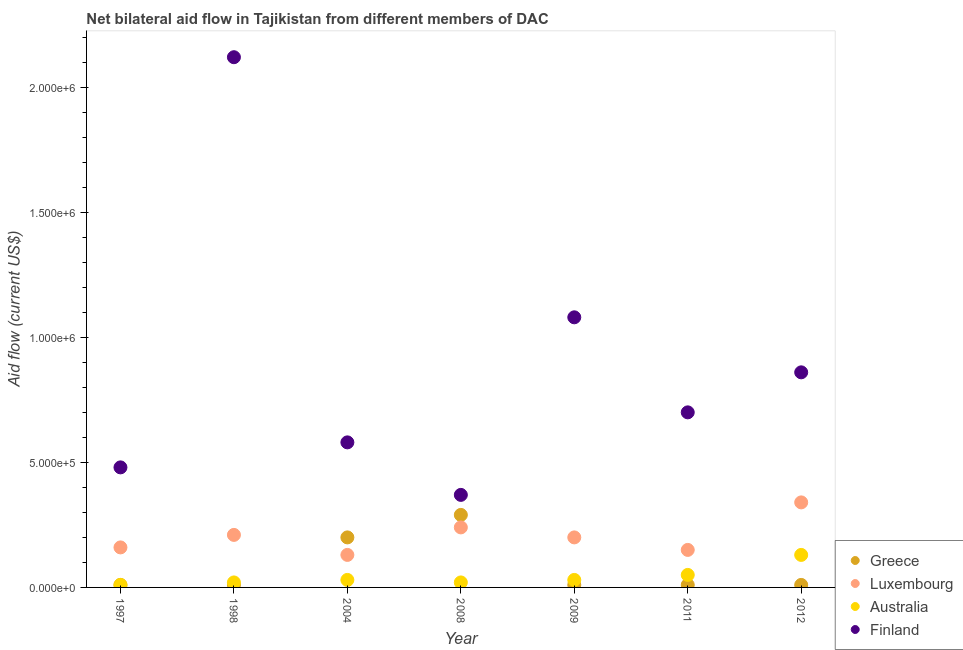How many different coloured dotlines are there?
Offer a very short reply. 4. Is the number of dotlines equal to the number of legend labels?
Your response must be concise. Yes. What is the amount of aid given by greece in 2004?
Ensure brevity in your answer.  2.00e+05. Across all years, what is the maximum amount of aid given by luxembourg?
Offer a very short reply. 3.40e+05. Across all years, what is the minimum amount of aid given by luxembourg?
Provide a short and direct response. 1.30e+05. In which year was the amount of aid given by greece maximum?
Your response must be concise. 2008. What is the total amount of aid given by luxembourg in the graph?
Your answer should be very brief. 1.43e+06. What is the difference between the amount of aid given by greece in 1997 and that in 2008?
Your response must be concise. -2.80e+05. What is the difference between the amount of aid given by greece in 2011 and the amount of aid given by australia in 2009?
Keep it short and to the point. -2.00e+04. What is the average amount of aid given by finland per year?
Make the answer very short. 8.84e+05. In the year 2009, what is the difference between the amount of aid given by luxembourg and amount of aid given by greece?
Offer a very short reply. 1.90e+05. What is the ratio of the amount of aid given by australia in 2011 to that in 2012?
Keep it short and to the point. 0.38. Is the difference between the amount of aid given by greece in 2004 and 2008 greater than the difference between the amount of aid given by luxembourg in 2004 and 2008?
Your answer should be very brief. Yes. What is the difference between the highest and the lowest amount of aid given by australia?
Give a very brief answer. 1.20e+05. In how many years, is the amount of aid given by luxembourg greater than the average amount of aid given by luxembourg taken over all years?
Offer a very short reply. 3. Is it the case that in every year, the sum of the amount of aid given by greece and amount of aid given by luxembourg is greater than the amount of aid given by australia?
Offer a very short reply. Yes. Does the amount of aid given by greece monotonically increase over the years?
Offer a very short reply. No. Is the amount of aid given by luxembourg strictly greater than the amount of aid given by finland over the years?
Ensure brevity in your answer.  No. Is the amount of aid given by finland strictly less than the amount of aid given by australia over the years?
Make the answer very short. No. How many dotlines are there?
Your answer should be compact. 4. What is the difference between two consecutive major ticks on the Y-axis?
Offer a very short reply. 5.00e+05. Where does the legend appear in the graph?
Keep it short and to the point. Bottom right. How many legend labels are there?
Your answer should be compact. 4. What is the title of the graph?
Your answer should be very brief. Net bilateral aid flow in Tajikistan from different members of DAC. Does "Secondary general education" appear as one of the legend labels in the graph?
Make the answer very short. No. What is the label or title of the X-axis?
Provide a succinct answer. Year. What is the Aid flow (current US$) in Greece in 1997?
Your answer should be very brief. 10000. What is the Aid flow (current US$) in Finland in 1997?
Offer a very short reply. 4.80e+05. What is the Aid flow (current US$) in Greece in 1998?
Offer a very short reply. 10000. What is the Aid flow (current US$) of Luxembourg in 1998?
Ensure brevity in your answer.  2.10e+05. What is the Aid flow (current US$) in Australia in 1998?
Offer a very short reply. 2.00e+04. What is the Aid flow (current US$) of Finland in 1998?
Keep it short and to the point. 2.12e+06. What is the Aid flow (current US$) of Greece in 2004?
Your answer should be compact. 2.00e+05. What is the Aid flow (current US$) in Australia in 2004?
Keep it short and to the point. 3.00e+04. What is the Aid flow (current US$) of Finland in 2004?
Ensure brevity in your answer.  5.80e+05. What is the Aid flow (current US$) of Greece in 2008?
Offer a very short reply. 2.90e+05. What is the Aid flow (current US$) in Australia in 2008?
Provide a succinct answer. 2.00e+04. What is the Aid flow (current US$) of Finland in 2008?
Provide a succinct answer. 3.70e+05. What is the Aid flow (current US$) of Greece in 2009?
Your answer should be compact. 10000. What is the Aid flow (current US$) in Australia in 2009?
Offer a very short reply. 3.00e+04. What is the Aid flow (current US$) of Finland in 2009?
Offer a terse response. 1.08e+06. What is the Aid flow (current US$) in Greece in 2011?
Keep it short and to the point. 10000. What is the Aid flow (current US$) of Australia in 2011?
Provide a short and direct response. 5.00e+04. What is the Aid flow (current US$) of Finland in 2011?
Your response must be concise. 7.00e+05. What is the Aid flow (current US$) in Luxembourg in 2012?
Give a very brief answer. 3.40e+05. What is the Aid flow (current US$) of Finland in 2012?
Provide a short and direct response. 8.60e+05. Across all years, what is the maximum Aid flow (current US$) in Finland?
Offer a terse response. 2.12e+06. Across all years, what is the minimum Aid flow (current US$) of Luxembourg?
Make the answer very short. 1.30e+05. Across all years, what is the minimum Aid flow (current US$) in Australia?
Your answer should be very brief. 10000. Across all years, what is the minimum Aid flow (current US$) of Finland?
Make the answer very short. 3.70e+05. What is the total Aid flow (current US$) in Greece in the graph?
Your answer should be very brief. 5.40e+05. What is the total Aid flow (current US$) of Luxembourg in the graph?
Offer a terse response. 1.43e+06. What is the total Aid flow (current US$) of Finland in the graph?
Make the answer very short. 6.19e+06. What is the difference between the Aid flow (current US$) in Finland in 1997 and that in 1998?
Offer a very short reply. -1.64e+06. What is the difference between the Aid flow (current US$) in Luxembourg in 1997 and that in 2004?
Your answer should be very brief. 3.00e+04. What is the difference between the Aid flow (current US$) in Australia in 1997 and that in 2004?
Give a very brief answer. -2.00e+04. What is the difference between the Aid flow (current US$) in Greece in 1997 and that in 2008?
Give a very brief answer. -2.80e+05. What is the difference between the Aid flow (current US$) of Australia in 1997 and that in 2008?
Make the answer very short. -10000. What is the difference between the Aid flow (current US$) in Greece in 1997 and that in 2009?
Offer a very short reply. 0. What is the difference between the Aid flow (current US$) of Luxembourg in 1997 and that in 2009?
Offer a very short reply. -4.00e+04. What is the difference between the Aid flow (current US$) of Australia in 1997 and that in 2009?
Offer a very short reply. -2.00e+04. What is the difference between the Aid flow (current US$) in Finland in 1997 and that in 2009?
Provide a short and direct response. -6.00e+05. What is the difference between the Aid flow (current US$) in Greece in 1997 and that in 2011?
Make the answer very short. 0. What is the difference between the Aid flow (current US$) in Luxembourg in 1997 and that in 2011?
Ensure brevity in your answer.  10000. What is the difference between the Aid flow (current US$) in Luxembourg in 1997 and that in 2012?
Provide a short and direct response. -1.80e+05. What is the difference between the Aid flow (current US$) of Finland in 1997 and that in 2012?
Ensure brevity in your answer.  -3.80e+05. What is the difference between the Aid flow (current US$) of Greece in 1998 and that in 2004?
Provide a short and direct response. -1.90e+05. What is the difference between the Aid flow (current US$) of Finland in 1998 and that in 2004?
Keep it short and to the point. 1.54e+06. What is the difference between the Aid flow (current US$) of Greece in 1998 and that in 2008?
Offer a very short reply. -2.80e+05. What is the difference between the Aid flow (current US$) in Luxembourg in 1998 and that in 2008?
Make the answer very short. -3.00e+04. What is the difference between the Aid flow (current US$) in Australia in 1998 and that in 2008?
Offer a terse response. 0. What is the difference between the Aid flow (current US$) of Finland in 1998 and that in 2008?
Keep it short and to the point. 1.75e+06. What is the difference between the Aid flow (current US$) in Australia in 1998 and that in 2009?
Offer a very short reply. -10000. What is the difference between the Aid flow (current US$) in Finland in 1998 and that in 2009?
Provide a succinct answer. 1.04e+06. What is the difference between the Aid flow (current US$) in Greece in 1998 and that in 2011?
Provide a short and direct response. 0. What is the difference between the Aid flow (current US$) of Luxembourg in 1998 and that in 2011?
Your answer should be very brief. 6.00e+04. What is the difference between the Aid flow (current US$) in Australia in 1998 and that in 2011?
Your answer should be very brief. -3.00e+04. What is the difference between the Aid flow (current US$) in Finland in 1998 and that in 2011?
Offer a very short reply. 1.42e+06. What is the difference between the Aid flow (current US$) of Greece in 1998 and that in 2012?
Give a very brief answer. 0. What is the difference between the Aid flow (current US$) of Luxembourg in 1998 and that in 2012?
Provide a short and direct response. -1.30e+05. What is the difference between the Aid flow (current US$) of Finland in 1998 and that in 2012?
Provide a succinct answer. 1.26e+06. What is the difference between the Aid flow (current US$) of Luxembourg in 2004 and that in 2008?
Make the answer very short. -1.10e+05. What is the difference between the Aid flow (current US$) of Australia in 2004 and that in 2008?
Ensure brevity in your answer.  10000. What is the difference between the Aid flow (current US$) of Australia in 2004 and that in 2009?
Ensure brevity in your answer.  0. What is the difference between the Aid flow (current US$) in Finland in 2004 and that in 2009?
Offer a terse response. -5.00e+05. What is the difference between the Aid flow (current US$) of Greece in 2004 and that in 2011?
Ensure brevity in your answer.  1.90e+05. What is the difference between the Aid flow (current US$) in Luxembourg in 2004 and that in 2011?
Ensure brevity in your answer.  -2.00e+04. What is the difference between the Aid flow (current US$) in Australia in 2004 and that in 2011?
Give a very brief answer. -2.00e+04. What is the difference between the Aid flow (current US$) in Greece in 2004 and that in 2012?
Your response must be concise. 1.90e+05. What is the difference between the Aid flow (current US$) of Australia in 2004 and that in 2012?
Offer a very short reply. -1.00e+05. What is the difference between the Aid flow (current US$) of Finland in 2004 and that in 2012?
Your response must be concise. -2.80e+05. What is the difference between the Aid flow (current US$) of Luxembourg in 2008 and that in 2009?
Provide a succinct answer. 4.00e+04. What is the difference between the Aid flow (current US$) of Australia in 2008 and that in 2009?
Your response must be concise. -10000. What is the difference between the Aid flow (current US$) of Finland in 2008 and that in 2009?
Your response must be concise. -7.10e+05. What is the difference between the Aid flow (current US$) in Greece in 2008 and that in 2011?
Make the answer very short. 2.80e+05. What is the difference between the Aid flow (current US$) of Finland in 2008 and that in 2011?
Provide a succinct answer. -3.30e+05. What is the difference between the Aid flow (current US$) in Finland in 2008 and that in 2012?
Give a very brief answer. -4.90e+05. What is the difference between the Aid flow (current US$) of Luxembourg in 2009 and that in 2011?
Your response must be concise. 5.00e+04. What is the difference between the Aid flow (current US$) in Australia in 2009 and that in 2011?
Give a very brief answer. -2.00e+04. What is the difference between the Aid flow (current US$) in Greece in 2009 and that in 2012?
Offer a very short reply. 0. What is the difference between the Aid flow (current US$) of Luxembourg in 2009 and that in 2012?
Provide a short and direct response. -1.40e+05. What is the difference between the Aid flow (current US$) in Finland in 2009 and that in 2012?
Your answer should be very brief. 2.20e+05. What is the difference between the Aid flow (current US$) of Luxembourg in 2011 and that in 2012?
Make the answer very short. -1.90e+05. What is the difference between the Aid flow (current US$) in Australia in 2011 and that in 2012?
Your answer should be compact. -8.00e+04. What is the difference between the Aid flow (current US$) of Finland in 2011 and that in 2012?
Your answer should be compact. -1.60e+05. What is the difference between the Aid flow (current US$) of Greece in 1997 and the Aid flow (current US$) of Luxembourg in 1998?
Your response must be concise. -2.00e+05. What is the difference between the Aid flow (current US$) of Greece in 1997 and the Aid flow (current US$) of Finland in 1998?
Make the answer very short. -2.11e+06. What is the difference between the Aid flow (current US$) of Luxembourg in 1997 and the Aid flow (current US$) of Finland in 1998?
Provide a succinct answer. -1.96e+06. What is the difference between the Aid flow (current US$) of Australia in 1997 and the Aid flow (current US$) of Finland in 1998?
Provide a succinct answer. -2.11e+06. What is the difference between the Aid flow (current US$) in Greece in 1997 and the Aid flow (current US$) in Finland in 2004?
Give a very brief answer. -5.70e+05. What is the difference between the Aid flow (current US$) of Luxembourg in 1997 and the Aid flow (current US$) of Australia in 2004?
Your answer should be very brief. 1.30e+05. What is the difference between the Aid flow (current US$) of Luxembourg in 1997 and the Aid flow (current US$) of Finland in 2004?
Your answer should be very brief. -4.20e+05. What is the difference between the Aid flow (current US$) of Australia in 1997 and the Aid flow (current US$) of Finland in 2004?
Your answer should be very brief. -5.70e+05. What is the difference between the Aid flow (current US$) in Greece in 1997 and the Aid flow (current US$) in Luxembourg in 2008?
Provide a succinct answer. -2.30e+05. What is the difference between the Aid flow (current US$) in Greece in 1997 and the Aid flow (current US$) in Australia in 2008?
Your response must be concise. -10000. What is the difference between the Aid flow (current US$) of Greece in 1997 and the Aid flow (current US$) of Finland in 2008?
Give a very brief answer. -3.60e+05. What is the difference between the Aid flow (current US$) in Australia in 1997 and the Aid flow (current US$) in Finland in 2008?
Make the answer very short. -3.60e+05. What is the difference between the Aid flow (current US$) in Greece in 1997 and the Aid flow (current US$) in Australia in 2009?
Make the answer very short. -2.00e+04. What is the difference between the Aid flow (current US$) of Greece in 1997 and the Aid flow (current US$) of Finland in 2009?
Provide a succinct answer. -1.07e+06. What is the difference between the Aid flow (current US$) of Luxembourg in 1997 and the Aid flow (current US$) of Finland in 2009?
Your answer should be compact. -9.20e+05. What is the difference between the Aid flow (current US$) in Australia in 1997 and the Aid flow (current US$) in Finland in 2009?
Make the answer very short. -1.07e+06. What is the difference between the Aid flow (current US$) in Greece in 1997 and the Aid flow (current US$) in Luxembourg in 2011?
Ensure brevity in your answer.  -1.40e+05. What is the difference between the Aid flow (current US$) in Greece in 1997 and the Aid flow (current US$) in Finland in 2011?
Provide a succinct answer. -6.90e+05. What is the difference between the Aid flow (current US$) in Luxembourg in 1997 and the Aid flow (current US$) in Australia in 2011?
Ensure brevity in your answer.  1.10e+05. What is the difference between the Aid flow (current US$) in Luxembourg in 1997 and the Aid flow (current US$) in Finland in 2011?
Your answer should be very brief. -5.40e+05. What is the difference between the Aid flow (current US$) in Australia in 1997 and the Aid flow (current US$) in Finland in 2011?
Offer a very short reply. -6.90e+05. What is the difference between the Aid flow (current US$) in Greece in 1997 and the Aid flow (current US$) in Luxembourg in 2012?
Provide a succinct answer. -3.30e+05. What is the difference between the Aid flow (current US$) of Greece in 1997 and the Aid flow (current US$) of Finland in 2012?
Keep it short and to the point. -8.50e+05. What is the difference between the Aid flow (current US$) in Luxembourg in 1997 and the Aid flow (current US$) in Finland in 2012?
Offer a terse response. -7.00e+05. What is the difference between the Aid flow (current US$) in Australia in 1997 and the Aid flow (current US$) in Finland in 2012?
Your answer should be very brief. -8.50e+05. What is the difference between the Aid flow (current US$) in Greece in 1998 and the Aid flow (current US$) in Luxembourg in 2004?
Provide a short and direct response. -1.20e+05. What is the difference between the Aid flow (current US$) in Greece in 1998 and the Aid flow (current US$) in Australia in 2004?
Make the answer very short. -2.00e+04. What is the difference between the Aid flow (current US$) in Greece in 1998 and the Aid flow (current US$) in Finland in 2004?
Your response must be concise. -5.70e+05. What is the difference between the Aid flow (current US$) in Luxembourg in 1998 and the Aid flow (current US$) in Finland in 2004?
Ensure brevity in your answer.  -3.70e+05. What is the difference between the Aid flow (current US$) in Australia in 1998 and the Aid flow (current US$) in Finland in 2004?
Provide a succinct answer. -5.60e+05. What is the difference between the Aid flow (current US$) of Greece in 1998 and the Aid flow (current US$) of Luxembourg in 2008?
Offer a very short reply. -2.30e+05. What is the difference between the Aid flow (current US$) in Greece in 1998 and the Aid flow (current US$) in Finland in 2008?
Provide a short and direct response. -3.60e+05. What is the difference between the Aid flow (current US$) in Luxembourg in 1998 and the Aid flow (current US$) in Australia in 2008?
Your answer should be very brief. 1.90e+05. What is the difference between the Aid flow (current US$) in Australia in 1998 and the Aid flow (current US$) in Finland in 2008?
Offer a terse response. -3.50e+05. What is the difference between the Aid flow (current US$) in Greece in 1998 and the Aid flow (current US$) in Australia in 2009?
Give a very brief answer. -2.00e+04. What is the difference between the Aid flow (current US$) in Greece in 1998 and the Aid flow (current US$) in Finland in 2009?
Offer a very short reply. -1.07e+06. What is the difference between the Aid flow (current US$) of Luxembourg in 1998 and the Aid flow (current US$) of Australia in 2009?
Your answer should be compact. 1.80e+05. What is the difference between the Aid flow (current US$) of Luxembourg in 1998 and the Aid flow (current US$) of Finland in 2009?
Provide a short and direct response. -8.70e+05. What is the difference between the Aid flow (current US$) in Australia in 1998 and the Aid flow (current US$) in Finland in 2009?
Your answer should be compact. -1.06e+06. What is the difference between the Aid flow (current US$) of Greece in 1998 and the Aid flow (current US$) of Luxembourg in 2011?
Give a very brief answer. -1.40e+05. What is the difference between the Aid flow (current US$) in Greece in 1998 and the Aid flow (current US$) in Australia in 2011?
Keep it short and to the point. -4.00e+04. What is the difference between the Aid flow (current US$) of Greece in 1998 and the Aid flow (current US$) of Finland in 2011?
Make the answer very short. -6.90e+05. What is the difference between the Aid flow (current US$) of Luxembourg in 1998 and the Aid flow (current US$) of Australia in 2011?
Your answer should be compact. 1.60e+05. What is the difference between the Aid flow (current US$) in Luxembourg in 1998 and the Aid flow (current US$) in Finland in 2011?
Your answer should be very brief. -4.90e+05. What is the difference between the Aid flow (current US$) in Australia in 1998 and the Aid flow (current US$) in Finland in 2011?
Give a very brief answer. -6.80e+05. What is the difference between the Aid flow (current US$) in Greece in 1998 and the Aid flow (current US$) in Luxembourg in 2012?
Make the answer very short. -3.30e+05. What is the difference between the Aid flow (current US$) of Greece in 1998 and the Aid flow (current US$) of Australia in 2012?
Make the answer very short. -1.20e+05. What is the difference between the Aid flow (current US$) in Greece in 1998 and the Aid flow (current US$) in Finland in 2012?
Give a very brief answer. -8.50e+05. What is the difference between the Aid flow (current US$) in Luxembourg in 1998 and the Aid flow (current US$) in Finland in 2012?
Your response must be concise. -6.50e+05. What is the difference between the Aid flow (current US$) in Australia in 1998 and the Aid flow (current US$) in Finland in 2012?
Make the answer very short. -8.40e+05. What is the difference between the Aid flow (current US$) in Greece in 2004 and the Aid flow (current US$) in Luxembourg in 2008?
Your answer should be very brief. -4.00e+04. What is the difference between the Aid flow (current US$) in Greece in 2004 and the Aid flow (current US$) in Finland in 2008?
Offer a terse response. -1.70e+05. What is the difference between the Aid flow (current US$) of Australia in 2004 and the Aid flow (current US$) of Finland in 2008?
Make the answer very short. -3.40e+05. What is the difference between the Aid flow (current US$) in Greece in 2004 and the Aid flow (current US$) in Finland in 2009?
Provide a short and direct response. -8.80e+05. What is the difference between the Aid flow (current US$) of Luxembourg in 2004 and the Aid flow (current US$) of Australia in 2009?
Make the answer very short. 1.00e+05. What is the difference between the Aid flow (current US$) of Luxembourg in 2004 and the Aid flow (current US$) of Finland in 2009?
Provide a succinct answer. -9.50e+05. What is the difference between the Aid flow (current US$) of Australia in 2004 and the Aid flow (current US$) of Finland in 2009?
Ensure brevity in your answer.  -1.05e+06. What is the difference between the Aid flow (current US$) in Greece in 2004 and the Aid flow (current US$) in Finland in 2011?
Provide a short and direct response. -5.00e+05. What is the difference between the Aid flow (current US$) in Luxembourg in 2004 and the Aid flow (current US$) in Australia in 2011?
Your answer should be compact. 8.00e+04. What is the difference between the Aid flow (current US$) of Luxembourg in 2004 and the Aid flow (current US$) of Finland in 2011?
Offer a terse response. -5.70e+05. What is the difference between the Aid flow (current US$) in Australia in 2004 and the Aid flow (current US$) in Finland in 2011?
Your response must be concise. -6.70e+05. What is the difference between the Aid flow (current US$) of Greece in 2004 and the Aid flow (current US$) of Luxembourg in 2012?
Provide a short and direct response. -1.40e+05. What is the difference between the Aid flow (current US$) in Greece in 2004 and the Aid flow (current US$) in Finland in 2012?
Ensure brevity in your answer.  -6.60e+05. What is the difference between the Aid flow (current US$) of Luxembourg in 2004 and the Aid flow (current US$) of Australia in 2012?
Your answer should be very brief. 0. What is the difference between the Aid flow (current US$) in Luxembourg in 2004 and the Aid flow (current US$) in Finland in 2012?
Provide a short and direct response. -7.30e+05. What is the difference between the Aid flow (current US$) of Australia in 2004 and the Aid flow (current US$) of Finland in 2012?
Your response must be concise. -8.30e+05. What is the difference between the Aid flow (current US$) in Greece in 2008 and the Aid flow (current US$) in Finland in 2009?
Ensure brevity in your answer.  -7.90e+05. What is the difference between the Aid flow (current US$) in Luxembourg in 2008 and the Aid flow (current US$) in Australia in 2009?
Ensure brevity in your answer.  2.10e+05. What is the difference between the Aid flow (current US$) of Luxembourg in 2008 and the Aid flow (current US$) of Finland in 2009?
Offer a very short reply. -8.40e+05. What is the difference between the Aid flow (current US$) in Australia in 2008 and the Aid flow (current US$) in Finland in 2009?
Make the answer very short. -1.06e+06. What is the difference between the Aid flow (current US$) of Greece in 2008 and the Aid flow (current US$) of Australia in 2011?
Offer a very short reply. 2.40e+05. What is the difference between the Aid flow (current US$) of Greece in 2008 and the Aid flow (current US$) of Finland in 2011?
Provide a short and direct response. -4.10e+05. What is the difference between the Aid flow (current US$) in Luxembourg in 2008 and the Aid flow (current US$) in Finland in 2011?
Make the answer very short. -4.60e+05. What is the difference between the Aid flow (current US$) in Australia in 2008 and the Aid flow (current US$) in Finland in 2011?
Offer a terse response. -6.80e+05. What is the difference between the Aid flow (current US$) of Greece in 2008 and the Aid flow (current US$) of Luxembourg in 2012?
Your answer should be compact. -5.00e+04. What is the difference between the Aid flow (current US$) of Greece in 2008 and the Aid flow (current US$) of Australia in 2012?
Keep it short and to the point. 1.60e+05. What is the difference between the Aid flow (current US$) in Greece in 2008 and the Aid flow (current US$) in Finland in 2012?
Provide a short and direct response. -5.70e+05. What is the difference between the Aid flow (current US$) of Luxembourg in 2008 and the Aid flow (current US$) of Australia in 2012?
Offer a terse response. 1.10e+05. What is the difference between the Aid flow (current US$) of Luxembourg in 2008 and the Aid flow (current US$) of Finland in 2012?
Make the answer very short. -6.20e+05. What is the difference between the Aid flow (current US$) in Australia in 2008 and the Aid flow (current US$) in Finland in 2012?
Ensure brevity in your answer.  -8.40e+05. What is the difference between the Aid flow (current US$) in Greece in 2009 and the Aid flow (current US$) in Luxembourg in 2011?
Your answer should be very brief. -1.40e+05. What is the difference between the Aid flow (current US$) in Greece in 2009 and the Aid flow (current US$) in Finland in 2011?
Your answer should be very brief. -6.90e+05. What is the difference between the Aid flow (current US$) of Luxembourg in 2009 and the Aid flow (current US$) of Finland in 2011?
Your response must be concise. -5.00e+05. What is the difference between the Aid flow (current US$) of Australia in 2009 and the Aid flow (current US$) of Finland in 2011?
Your answer should be very brief. -6.70e+05. What is the difference between the Aid flow (current US$) in Greece in 2009 and the Aid flow (current US$) in Luxembourg in 2012?
Provide a short and direct response. -3.30e+05. What is the difference between the Aid flow (current US$) in Greece in 2009 and the Aid flow (current US$) in Australia in 2012?
Give a very brief answer. -1.20e+05. What is the difference between the Aid flow (current US$) in Greece in 2009 and the Aid flow (current US$) in Finland in 2012?
Offer a terse response. -8.50e+05. What is the difference between the Aid flow (current US$) in Luxembourg in 2009 and the Aid flow (current US$) in Australia in 2012?
Your answer should be compact. 7.00e+04. What is the difference between the Aid flow (current US$) in Luxembourg in 2009 and the Aid flow (current US$) in Finland in 2012?
Your answer should be compact. -6.60e+05. What is the difference between the Aid flow (current US$) in Australia in 2009 and the Aid flow (current US$) in Finland in 2012?
Your answer should be compact. -8.30e+05. What is the difference between the Aid flow (current US$) in Greece in 2011 and the Aid flow (current US$) in Luxembourg in 2012?
Offer a very short reply. -3.30e+05. What is the difference between the Aid flow (current US$) in Greece in 2011 and the Aid flow (current US$) in Finland in 2012?
Give a very brief answer. -8.50e+05. What is the difference between the Aid flow (current US$) in Luxembourg in 2011 and the Aid flow (current US$) in Australia in 2012?
Provide a short and direct response. 2.00e+04. What is the difference between the Aid flow (current US$) of Luxembourg in 2011 and the Aid flow (current US$) of Finland in 2012?
Offer a terse response. -7.10e+05. What is the difference between the Aid flow (current US$) in Australia in 2011 and the Aid flow (current US$) in Finland in 2012?
Provide a short and direct response. -8.10e+05. What is the average Aid flow (current US$) of Greece per year?
Your response must be concise. 7.71e+04. What is the average Aid flow (current US$) of Luxembourg per year?
Make the answer very short. 2.04e+05. What is the average Aid flow (current US$) of Australia per year?
Offer a very short reply. 4.14e+04. What is the average Aid flow (current US$) in Finland per year?
Offer a terse response. 8.84e+05. In the year 1997, what is the difference between the Aid flow (current US$) of Greece and Aid flow (current US$) of Luxembourg?
Offer a terse response. -1.50e+05. In the year 1997, what is the difference between the Aid flow (current US$) of Greece and Aid flow (current US$) of Australia?
Provide a short and direct response. 0. In the year 1997, what is the difference between the Aid flow (current US$) of Greece and Aid flow (current US$) of Finland?
Make the answer very short. -4.70e+05. In the year 1997, what is the difference between the Aid flow (current US$) of Luxembourg and Aid flow (current US$) of Finland?
Ensure brevity in your answer.  -3.20e+05. In the year 1997, what is the difference between the Aid flow (current US$) of Australia and Aid flow (current US$) of Finland?
Offer a very short reply. -4.70e+05. In the year 1998, what is the difference between the Aid flow (current US$) in Greece and Aid flow (current US$) in Australia?
Ensure brevity in your answer.  -10000. In the year 1998, what is the difference between the Aid flow (current US$) of Greece and Aid flow (current US$) of Finland?
Ensure brevity in your answer.  -2.11e+06. In the year 1998, what is the difference between the Aid flow (current US$) of Luxembourg and Aid flow (current US$) of Finland?
Your response must be concise. -1.91e+06. In the year 1998, what is the difference between the Aid flow (current US$) of Australia and Aid flow (current US$) of Finland?
Your answer should be very brief. -2.10e+06. In the year 2004, what is the difference between the Aid flow (current US$) in Greece and Aid flow (current US$) in Luxembourg?
Make the answer very short. 7.00e+04. In the year 2004, what is the difference between the Aid flow (current US$) in Greece and Aid flow (current US$) in Australia?
Make the answer very short. 1.70e+05. In the year 2004, what is the difference between the Aid flow (current US$) in Greece and Aid flow (current US$) in Finland?
Offer a terse response. -3.80e+05. In the year 2004, what is the difference between the Aid flow (current US$) of Luxembourg and Aid flow (current US$) of Australia?
Your answer should be compact. 1.00e+05. In the year 2004, what is the difference between the Aid flow (current US$) of Luxembourg and Aid flow (current US$) of Finland?
Your answer should be very brief. -4.50e+05. In the year 2004, what is the difference between the Aid flow (current US$) in Australia and Aid flow (current US$) in Finland?
Give a very brief answer. -5.50e+05. In the year 2008, what is the difference between the Aid flow (current US$) of Greece and Aid flow (current US$) of Finland?
Give a very brief answer. -8.00e+04. In the year 2008, what is the difference between the Aid flow (current US$) in Luxembourg and Aid flow (current US$) in Australia?
Your answer should be compact. 2.20e+05. In the year 2008, what is the difference between the Aid flow (current US$) of Australia and Aid flow (current US$) of Finland?
Make the answer very short. -3.50e+05. In the year 2009, what is the difference between the Aid flow (current US$) in Greece and Aid flow (current US$) in Luxembourg?
Give a very brief answer. -1.90e+05. In the year 2009, what is the difference between the Aid flow (current US$) in Greece and Aid flow (current US$) in Finland?
Your answer should be compact. -1.07e+06. In the year 2009, what is the difference between the Aid flow (current US$) of Luxembourg and Aid flow (current US$) of Finland?
Provide a short and direct response. -8.80e+05. In the year 2009, what is the difference between the Aid flow (current US$) in Australia and Aid flow (current US$) in Finland?
Offer a terse response. -1.05e+06. In the year 2011, what is the difference between the Aid flow (current US$) of Greece and Aid flow (current US$) of Luxembourg?
Your answer should be very brief. -1.40e+05. In the year 2011, what is the difference between the Aid flow (current US$) in Greece and Aid flow (current US$) in Finland?
Your response must be concise. -6.90e+05. In the year 2011, what is the difference between the Aid flow (current US$) of Luxembourg and Aid flow (current US$) of Finland?
Your answer should be compact. -5.50e+05. In the year 2011, what is the difference between the Aid flow (current US$) in Australia and Aid flow (current US$) in Finland?
Your answer should be very brief. -6.50e+05. In the year 2012, what is the difference between the Aid flow (current US$) of Greece and Aid flow (current US$) of Luxembourg?
Give a very brief answer. -3.30e+05. In the year 2012, what is the difference between the Aid flow (current US$) in Greece and Aid flow (current US$) in Australia?
Make the answer very short. -1.20e+05. In the year 2012, what is the difference between the Aid flow (current US$) in Greece and Aid flow (current US$) in Finland?
Your response must be concise. -8.50e+05. In the year 2012, what is the difference between the Aid flow (current US$) of Luxembourg and Aid flow (current US$) of Australia?
Offer a terse response. 2.10e+05. In the year 2012, what is the difference between the Aid flow (current US$) in Luxembourg and Aid flow (current US$) in Finland?
Provide a short and direct response. -5.20e+05. In the year 2012, what is the difference between the Aid flow (current US$) in Australia and Aid flow (current US$) in Finland?
Offer a terse response. -7.30e+05. What is the ratio of the Aid flow (current US$) of Greece in 1997 to that in 1998?
Provide a succinct answer. 1. What is the ratio of the Aid flow (current US$) in Luxembourg in 1997 to that in 1998?
Your answer should be very brief. 0.76. What is the ratio of the Aid flow (current US$) of Finland in 1997 to that in 1998?
Your answer should be compact. 0.23. What is the ratio of the Aid flow (current US$) in Luxembourg in 1997 to that in 2004?
Provide a succinct answer. 1.23. What is the ratio of the Aid flow (current US$) in Finland in 1997 to that in 2004?
Keep it short and to the point. 0.83. What is the ratio of the Aid flow (current US$) in Greece in 1997 to that in 2008?
Ensure brevity in your answer.  0.03. What is the ratio of the Aid flow (current US$) of Luxembourg in 1997 to that in 2008?
Offer a very short reply. 0.67. What is the ratio of the Aid flow (current US$) of Australia in 1997 to that in 2008?
Ensure brevity in your answer.  0.5. What is the ratio of the Aid flow (current US$) of Finland in 1997 to that in 2008?
Provide a succinct answer. 1.3. What is the ratio of the Aid flow (current US$) of Greece in 1997 to that in 2009?
Ensure brevity in your answer.  1. What is the ratio of the Aid flow (current US$) of Luxembourg in 1997 to that in 2009?
Offer a terse response. 0.8. What is the ratio of the Aid flow (current US$) in Australia in 1997 to that in 2009?
Make the answer very short. 0.33. What is the ratio of the Aid flow (current US$) of Finland in 1997 to that in 2009?
Keep it short and to the point. 0.44. What is the ratio of the Aid flow (current US$) of Greece in 1997 to that in 2011?
Offer a terse response. 1. What is the ratio of the Aid flow (current US$) in Luxembourg in 1997 to that in 2011?
Give a very brief answer. 1.07. What is the ratio of the Aid flow (current US$) of Australia in 1997 to that in 2011?
Provide a short and direct response. 0.2. What is the ratio of the Aid flow (current US$) of Finland in 1997 to that in 2011?
Your response must be concise. 0.69. What is the ratio of the Aid flow (current US$) in Greece in 1997 to that in 2012?
Provide a short and direct response. 1. What is the ratio of the Aid flow (current US$) of Luxembourg in 1997 to that in 2012?
Provide a short and direct response. 0.47. What is the ratio of the Aid flow (current US$) of Australia in 1997 to that in 2012?
Provide a short and direct response. 0.08. What is the ratio of the Aid flow (current US$) in Finland in 1997 to that in 2012?
Offer a very short reply. 0.56. What is the ratio of the Aid flow (current US$) in Luxembourg in 1998 to that in 2004?
Offer a very short reply. 1.62. What is the ratio of the Aid flow (current US$) of Australia in 1998 to that in 2004?
Make the answer very short. 0.67. What is the ratio of the Aid flow (current US$) of Finland in 1998 to that in 2004?
Your answer should be very brief. 3.66. What is the ratio of the Aid flow (current US$) of Greece in 1998 to that in 2008?
Ensure brevity in your answer.  0.03. What is the ratio of the Aid flow (current US$) of Finland in 1998 to that in 2008?
Keep it short and to the point. 5.73. What is the ratio of the Aid flow (current US$) of Greece in 1998 to that in 2009?
Provide a succinct answer. 1. What is the ratio of the Aid flow (current US$) of Luxembourg in 1998 to that in 2009?
Offer a terse response. 1.05. What is the ratio of the Aid flow (current US$) of Australia in 1998 to that in 2009?
Offer a terse response. 0.67. What is the ratio of the Aid flow (current US$) in Finland in 1998 to that in 2009?
Provide a short and direct response. 1.96. What is the ratio of the Aid flow (current US$) of Finland in 1998 to that in 2011?
Give a very brief answer. 3.03. What is the ratio of the Aid flow (current US$) of Greece in 1998 to that in 2012?
Keep it short and to the point. 1. What is the ratio of the Aid flow (current US$) of Luxembourg in 1998 to that in 2012?
Your answer should be very brief. 0.62. What is the ratio of the Aid flow (current US$) of Australia in 1998 to that in 2012?
Provide a short and direct response. 0.15. What is the ratio of the Aid flow (current US$) in Finland in 1998 to that in 2012?
Offer a terse response. 2.47. What is the ratio of the Aid flow (current US$) of Greece in 2004 to that in 2008?
Your answer should be very brief. 0.69. What is the ratio of the Aid flow (current US$) of Luxembourg in 2004 to that in 2008?
Make the answer very short. 0.54. What is the ratio of the Aid flow (current US$) of Australia in 2004 to that in 2008?
Make the answer very short. 1.5. What is the ratio of the Aid flow (current US$) in Finland in 2004 to that in 2008?
Your answer should be very brief. 1.57. What is the ratio of the Aid flow (current US$) of Greece in 2004 to that in 2009?
Offer a very short reply. 20. What is the ratio of the Aid flow (current US$) in Luxembourg in 2004 to that in 2009?
Give a very brief answer. 0.65. What is the ratio of the Aid flow (current US$) in Finland in 2004 to that in 2009?
Make the answer very short. 0.54. What is the ratio of the Aid flow (current US$) in Greece in 2004 to that in 2011?
Provide a short and direct response. 20. What is the ratio of the Aid flow (current US$) in Luxembourg in 2004 to that in 2011?
Provide a short and direct response. 0.87. What is the ratio of the Aid flow (current US$) of Australia in 2004 to that in 2011?
Give a very brief answer. 0.6. What is the ratio of the Aid flow (current US$) in Finland in 2004 to that in 2011?
Your answer should be compact. 0.83. What is the ratio of the Aid flow (current US$) in Luxembourg in 2004 to that in 2012?
Provide a short and direct response. 0.38. What is the ratio of the Aid flow (current US$) of Australia in 2004 to that in 2012?
Provide a succinct answer. 0.23. What is the ratio of the Aid flow (current US$) of Finland in 2004 to that in 2012?
Offer a terse response. 0.67. What is the ratio of the Aid flow (current US$) in Luxembourg in 2008 to that in 2009?
Provide a short and direct response. 1.2. What is the ratio of the Aid flow (current US$) in Australia in 2008 to that in 2009?
Offer a very short reply. 0.67. What is the ratio of the Aid flow (current US$) in Finland in 2008 to that in 2009?
Your answer should be very brief. 0.34. What is the ratio of the Aid flow (current US$) of Greece in 2008 to that in 2011?
Keep it short and to the point. 29. What is the ratio of the Aid flow (current US$) of Luxembourg in 2008 to that in 2011?
Keep it short and to the point. 1.6. What is the ratio of the Aid flow (current US$) in Finland in 2008 to that in 2011?
Keep it short and to the point. 0.53. What is the ratio of the Aid flow (current US$) of Luxembourg in 2008 to that in 2012?
Give a very brief answer. 0.71. What is the ratio of the Aid flow (current US$) of Australia in 2008 to that in 2012?
Ensure brevity in your answer.  0.15. What is the ratio of the Aid flow (current US$) in Finland in 2008 to that in 2012?
Offer a very short reply. 0.43. What is the ratio of the Aid flow (current US$) of Australia in 2009 to that in 2011?
Make the answer very short. 0.6. What is the ratio of the Aid flow (current US$) in Finland in 2009 to that in 2011?
Provide a short and direct response. 1.54. What is the ratio of the Aid flow (current US$) in Luxembourg in 2009 to that in 2012?
Provide a succinct answer. 0.59. What is the ratio of the Aid flow (current US$) in Australia in 2009 to that in 2012?
Provide a succinct answer. 0.23. What is the ratio of the Aid flow (current US$) of Finland in 2009 to that in 2012?
Make the answer very short. 1.26. What is the ratio of the Aid flow (current US$) of Luxembourg in 2011 to that in 2012?
Make the answer very short. 0.44. What is the ratio of the Aid flow (current US$) in Australia in 2011 to that in 2012?
Give a very brief answer. 0.38. What is the ratio of the Aid flow (current US$) in Finland in 2011 to that in 2012?
Your answer should be very brief. 0.81. What is the difference between the highest and the second highest Aid flow (current US$) in Greece?
Ensure brevity in your answer.  9.00e+04. What is the difference between the highest and the second highest Aid flow (current US$) in Finland?
Give a very brief answer. 1.04e+06. What is the difference between the highest and the lowest Aid flow (current US$) of Luxembourg?
Your answer should be very brief. 2.10e+05. What is the difference between the highest and the lowest Aid flow (current US$) of Australia?
Your answer should be very brief. 1.20e+05. What is the difference between the highest and the lowest Aid flow (current US$) of Finland?
Provide a short and direct response. 1.75e+06. 